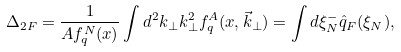Convert formula to latex. <formula><loc_0><loc_0><loc_500><loc_500>\Delta _ { 2 F } = \frac { 1 } { A f _ { q } ^ { N } ( x ) } \int d ^ { 2 } k _ { \perp } k _ { \perp } ^ { 2 } f _ { q } ^ { A } ( x , \vec { k } _ { \perp } ) = \int d \xi ^ { - } _ { N } \hat { q } _ { F } ( \xi _ { N } ) ,</formula> 